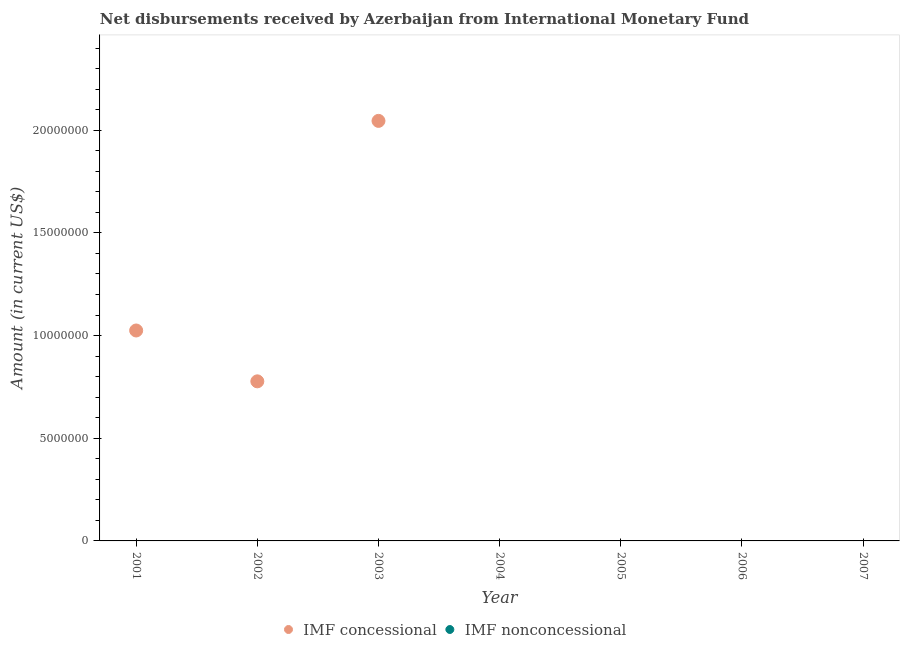Is the number of dotlines equal to the number of legend labels?
Offer a very short reply. No. What is the net concessional disbursements from imf in 2002?
Make the answer very short. 7.77e+06. Across all years, what is the maximum net concessional disbursements from imf?
Your answer should be very brief. 2.05e+07. In which year was the net concessional disbursements from imf maximum?
Offer a very short reply. 2003. What is the total net non concessional disbursements from imf in the graph?
Give a very brief answer. 0. What is the difference between the net non concessional disbursements from imf in 2002 and the net concessional disbursements from imf in 2004?
Keep it short and to the point. 0. What is the average net concessional disbursements from imf per year?
Keep it short and to the point. 5.50e+06. What is the difference between the highest and the second highest net concessional disbursements from imf?
Give a very brief answer. 1.02e+07. What is the difference between the highest and the lowest net concessional disbursements from imf?
Provide a succinct answer. 2.05e+07. Does the net non concessional disbursements from imf monotonically increase over the years?
Your answer should be compact. No. Is the net concessional disbursements from imf strictly greater than the net non concessional disbursements from imf over the years?
Give a very brief answer. No. Is the net concessional disbursements from imf strictly less than the net non concessional disbursements from imf over the years?
Provide a succinct answer. No. Are the values on the major ticks of Y-axis written in scientific E-notation?
Ensure brevity in your answer.  No. Where does the legend appear in the graph?
Provide a short and direct response. Bottom center. How are the legend labels stacked?
Offer a very short reply. Horizontal. What is the title of the graph?
Give a very brief answer. Net disbursements received by Azerbaijan from International Monetary Fund. Does "Banks" appear as one of the legend labels in the graph?
Your answer should be compact. No. What is the Amount (in current US$) in IMF concessional in 2001?
Provide a succinct answer. 1.02e+07. What is the Amount (in current US$) in IMF nonconcessional in 2001?
Give a very brief answer. 0. What is the Amount (in current US$) in IMF concessional in 2002?
Your answer should be very brief. 7.77e+06. What is the Amount (in current US$) in IMF concessional in 2003?
Ensure brevity in your answer.  2.05e+07. What is the Amount (in current US$) of IMF nonconcessional in 2003?
Keep it short and to the point. 0. What is the Amount (in current US$) in IMF nonconcessional in 2004?
Give a very brief answer. 0. What is the Amount (in current US$) in IMF nonconcessional in 2005?
Provide a short and direct response. 0. What is the Amount (in current US$) in IMF concessional in 2007?
Your answer should be compact. 0. Across all years, what is the maximum Amount (in current US$) in IMF concessional?
Provide a short and direct response. 2.05e+07. Across all years, what is the minimum Amount (in current US$) in IMF concessional?
Ensure brevity in your answer.  0. What is the total Amount (in current US$) in IMF concessional in the graph?
Make the answer very short. 3.85e+07. What is the difference between the Amount (in current US$) in IMF concessional in 2001 and that in 2002?
Offer a terse response. 2.48e+06. What is the difference between the Amount (in current US$) of IMF concessional in 2001 and that in 2003?
Provide a short and direct response. -1.02e+07. What is the difference between the Amount (in current US$) of IMF concessional in 2002 and that in 2003?
Ensure brevity in your answer.  -1.27e+07. What is the average Amount (in current US$) of IMF concessional per year?
Give a very brief answer. 5.50e+06. What is the average Amount (in current US$) of IMF nonconcessional per year?
Ensure brevity in your answer.  0. What is the ratio of the Amount (in current US$) in IMF concessional in 2001 to that in 2002?
Keep it short and to the point. 1.32. What is the ratio of the Amount (in current US$) of IMF concessional in 2001 to that in 2003?
Provide a short and direct response. 0.5. What is the ratio of the Amount (in current US$) in IMF concessional in 2002 to that in 2003?
Keep it short and to the point. 0.38. What is the difference between the highest and the second highest Amount (in current US$) of IMF concessional?
Provide a short and direct response. 1.02e+07. What is the difference between the highest and the lowest Amount (in current US$) of IMF concessional?
Your answer should be compact. 2.05e+07. 